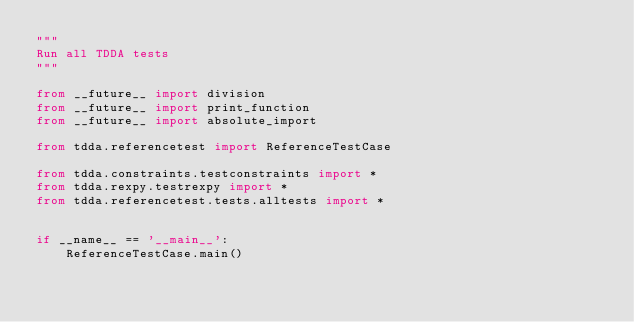Convert code to text. <code><loc_0><loc_0><loc_500><loc_500><_Python_>"""
Run all TDDA tests
"""

from __future__ import division
from __future__ import print_function
from __future__ import absolute_import

from tdda.referencetest import ReferenceTestCase

from tdda.constraints.testconstraints import *
from tdda.rexpy.testrexpy import *
from tdda.referencetest.tests.alltests import *


if __name__ == '__main__':
    ReferenceTestCase.main()

</code> 